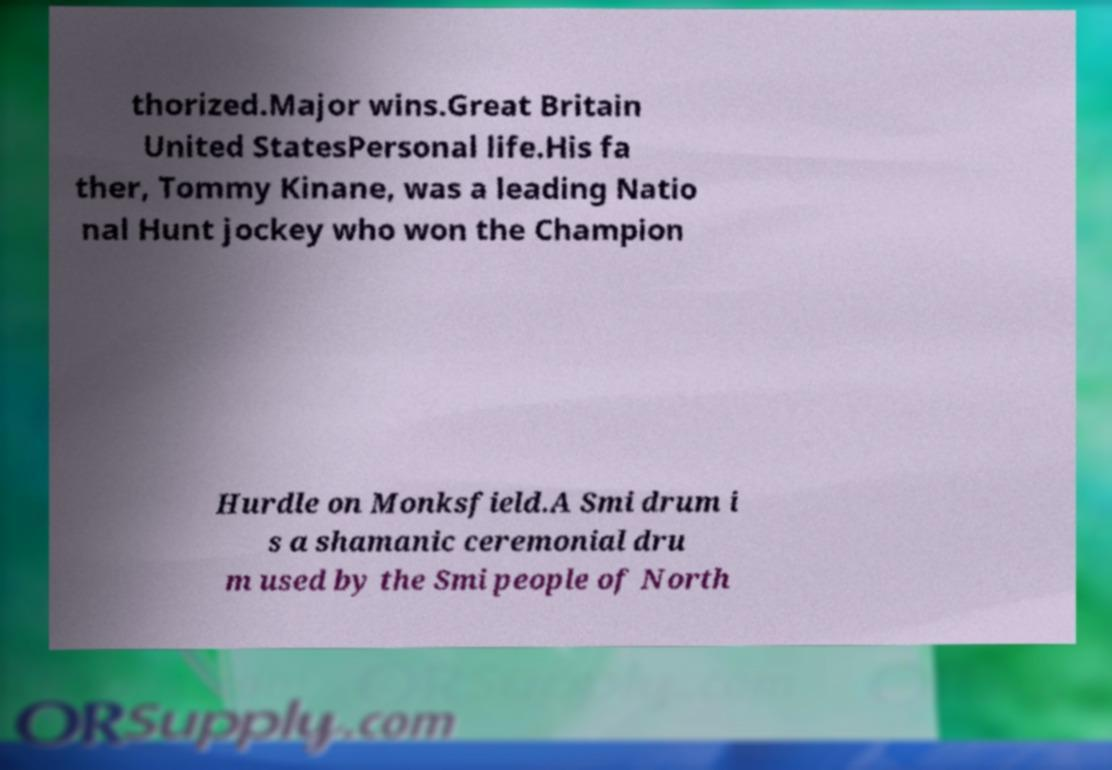Can you accurately transcribe the text from the provided image for me? thorized.Major wins.Great Britain United StatesPersonal life.His fa ther, Tommy Kinane, was a leading Natio nal Hunt jockey who won the Champion Hurdle on Monksfield.A Smi drum i s a shamanic ceremonial dru m used by the Smi people of North 